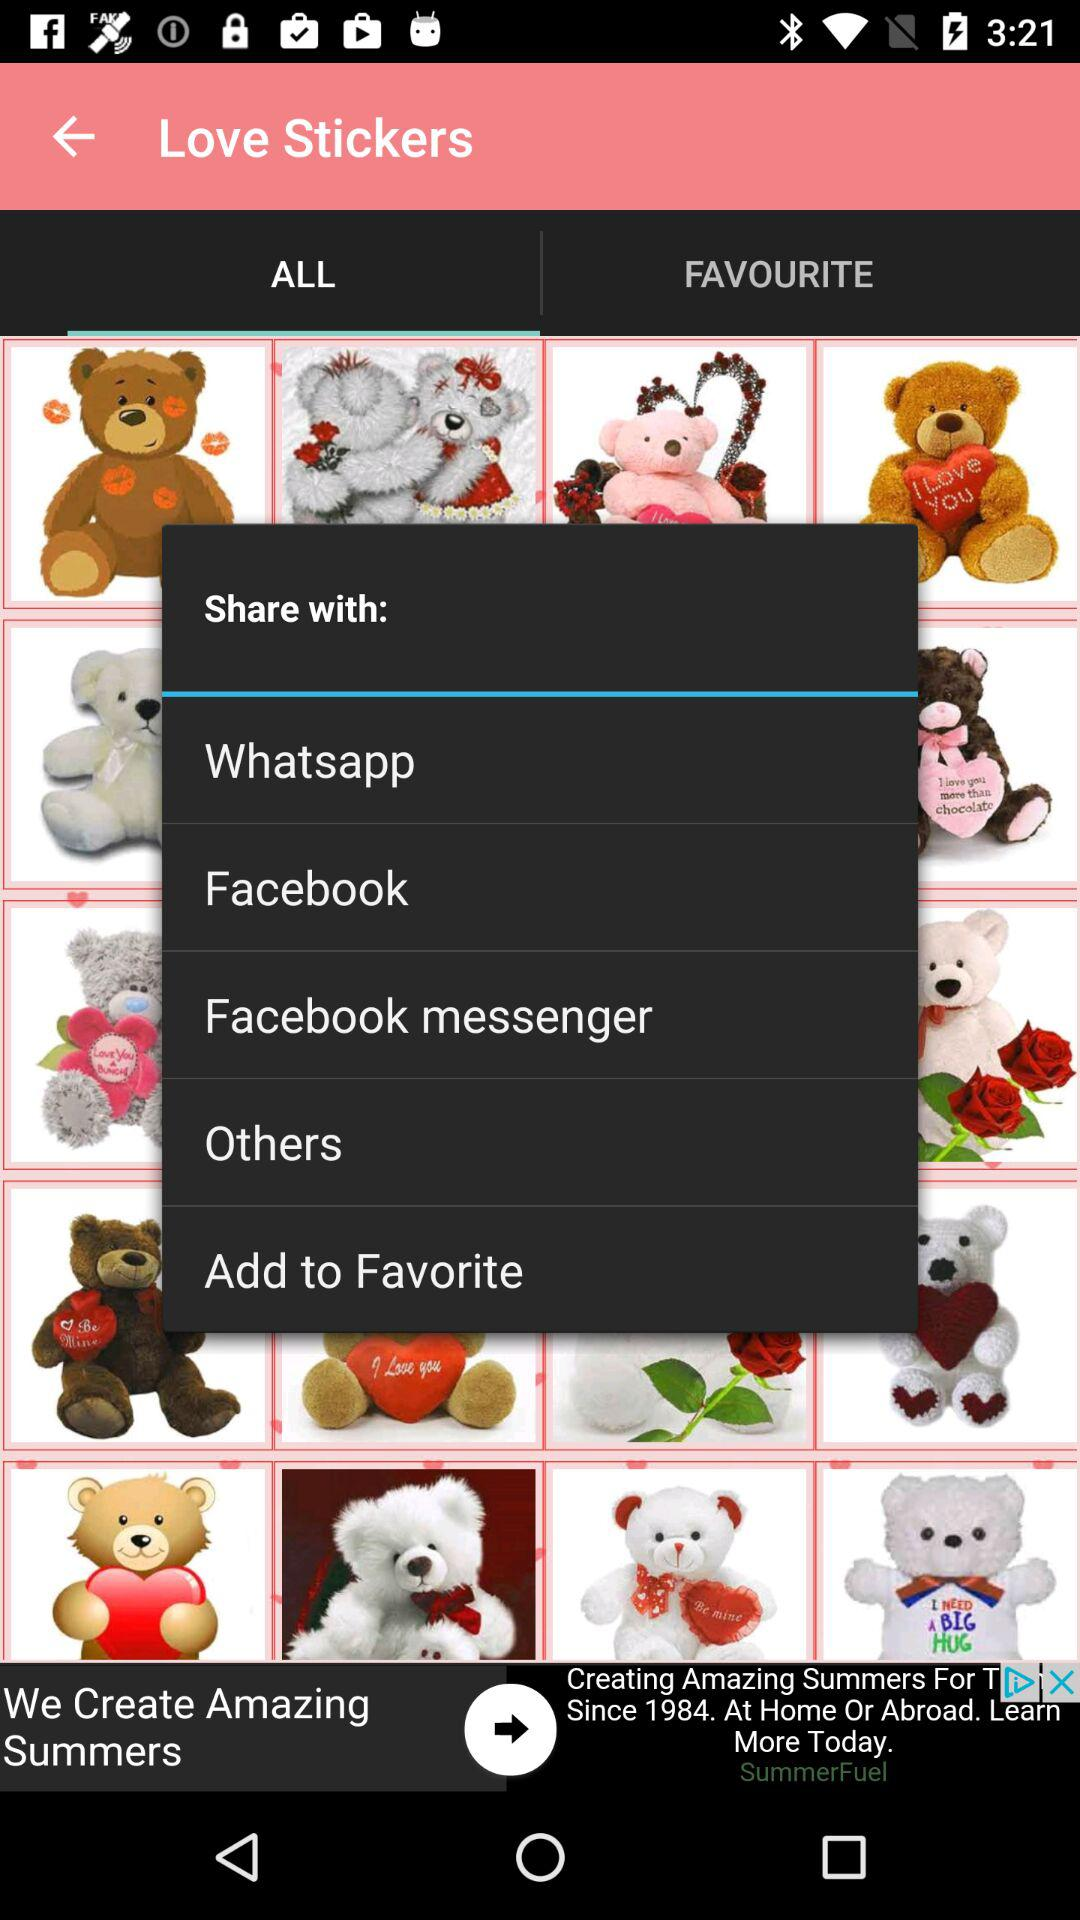Through which social app can we share love stickers? You can share it through "Whatsapp", "Facebook" and "Facebook messenger". 